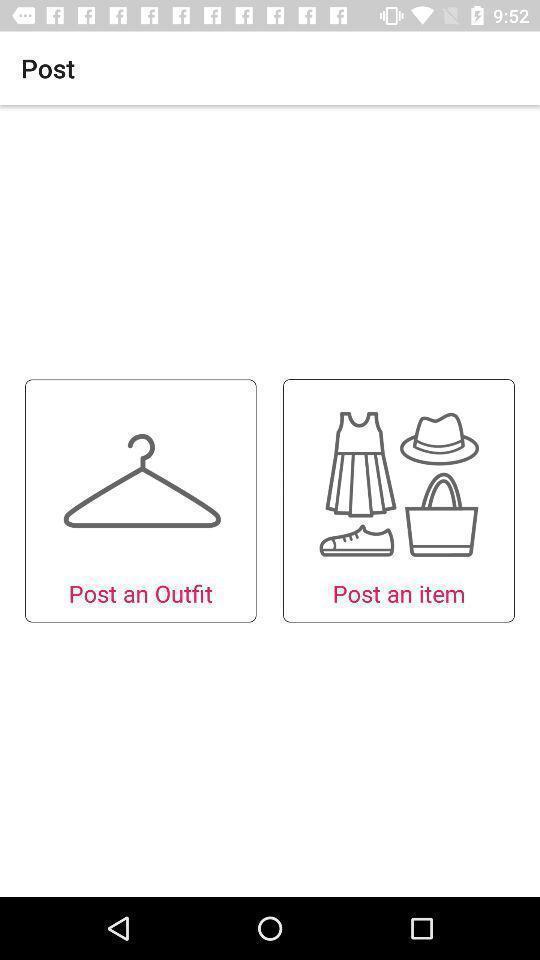Provide a detailed account of this screenshot. Welcoming page of a shopping app. 